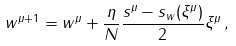<formula> <loc_0><loc_0><loc_500><loc_500>w ^ { \mu + 1 } = w ^ { \mu } + \frac { \eta } { N } \frac { s ^ { \mu } - s _ { w } ( \xi ^ { \mu } ) } { 2 } \xi ^ { \mu } \, ,</formula> 